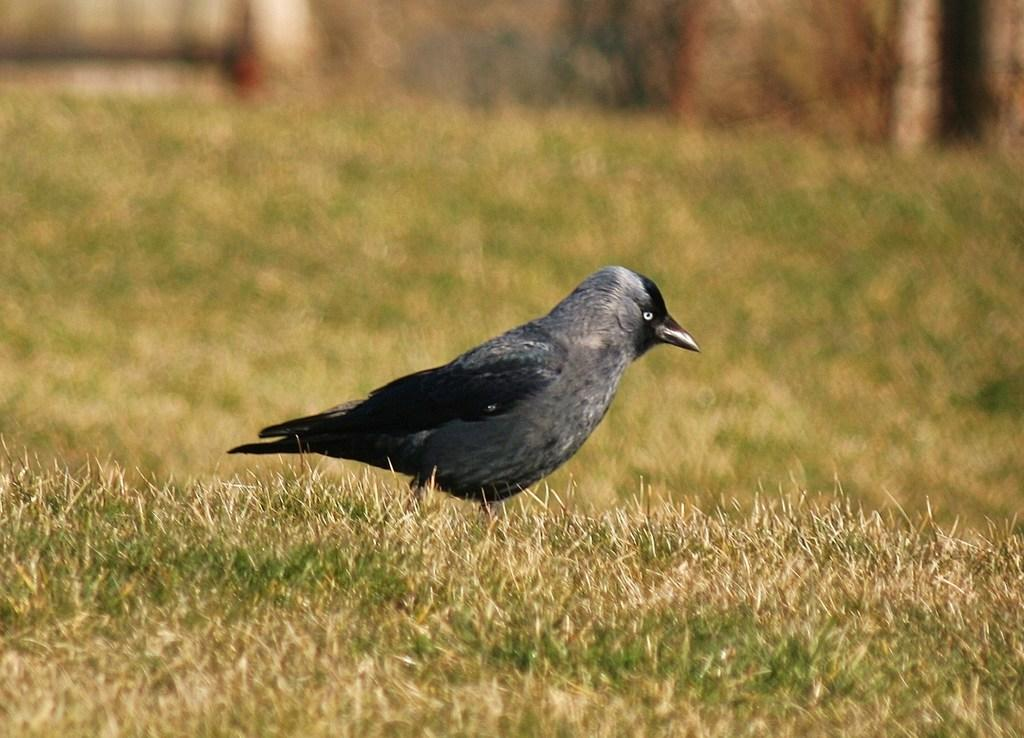What animal is in the center of the image? There is a crow in the center of the image. What type of vegetation can be seen in the background of the image? There is grass visible in the background of the image. How many boats are present in the image? There are no boats present in the image; it features a crow and grass. What type of crime is being committed in the image? There is no crime present in the image; it features a crow and grass. 